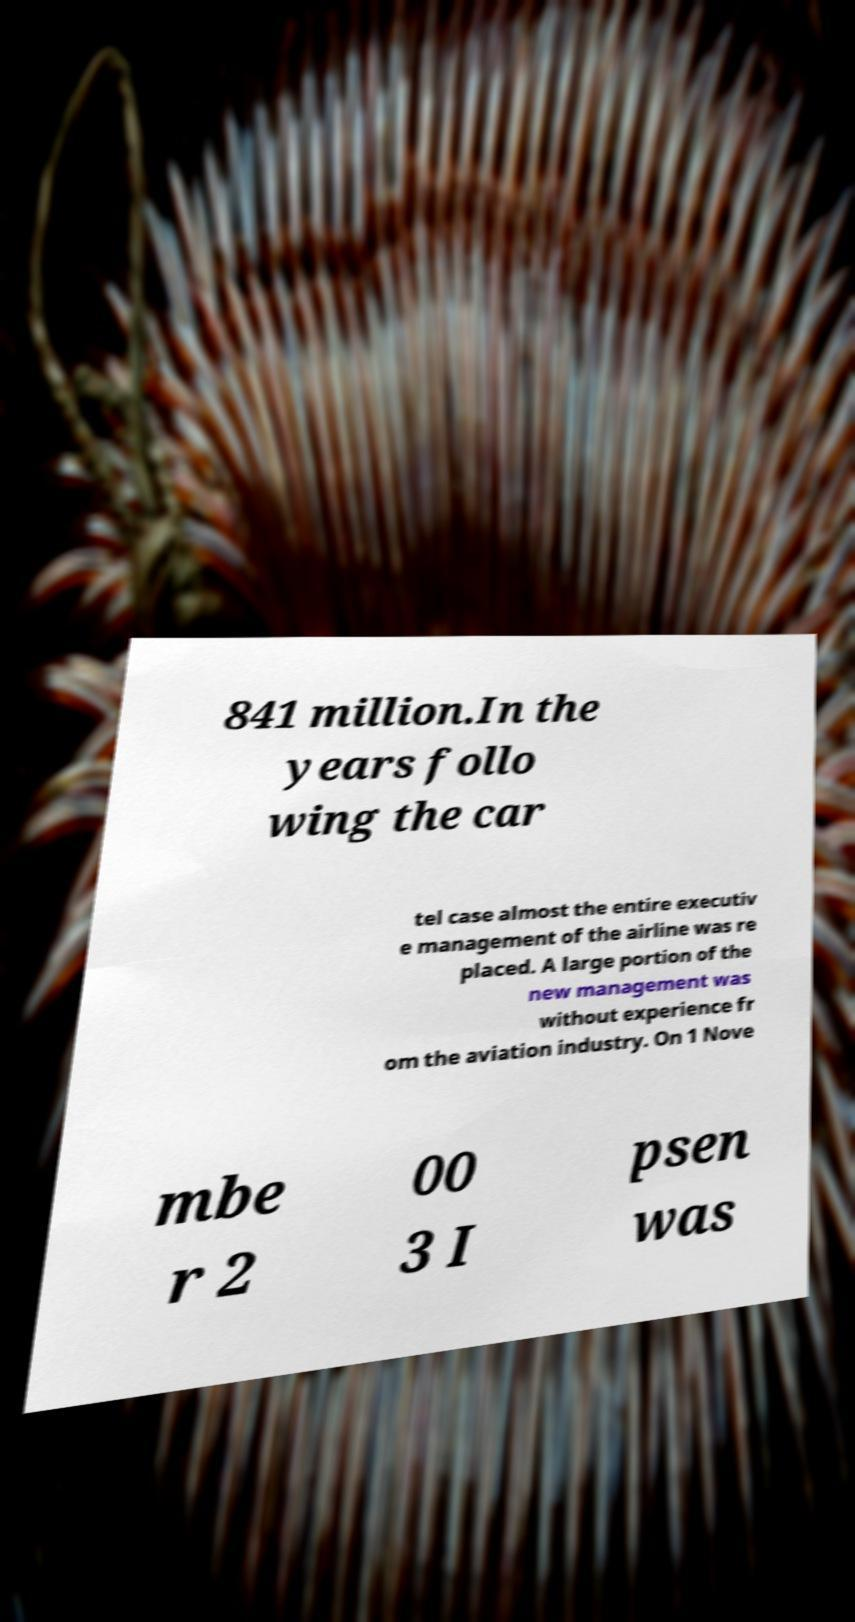Could you assist in decoding the text presented in this image and type it out clearly? 841 million.In the years follo wing the car tel case almost the entire executiv e management of the airline was re placed. A large portion of the new management was without experience fr om the aviation industry. On 1 Nove mbe r 2 00 3 I psen was 